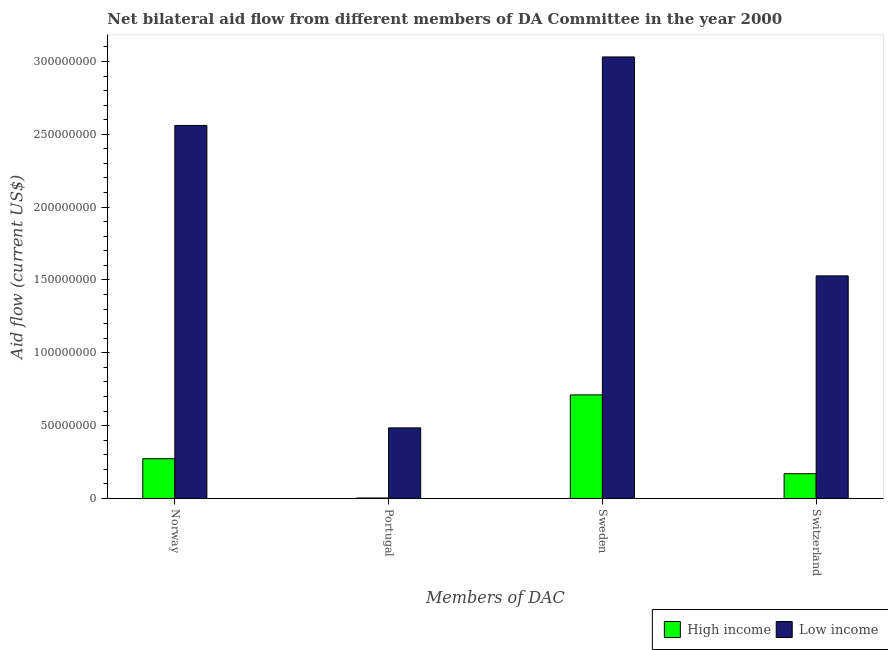How many different coloured bars are there?
Provide a succinct answer. 2. How many bars are there on the 4th tick from the left?
Make the answer very short. 2. How many bars are there on the 1st tick from the right?
Your answer should be very brief. 2. What is the amount of aid given by switzerland in High income?
Make the answer very short. 1.70e+07. Across all countries, what is the maximum amount of aid given by norway?
Offer a very short reply. 2.56e+08. Across all countries, what is the minimum amount of aid given by sweden?
Your answer should be compact. 7.11e+07. In which country was the amount of aid given by sweden maximum?
Your answer should be compact. Low income. What is the total amount of aid given by portugal in the graph?
Ensure brevity in your answer.  4.87e+07. What is the difference between the amount of aid given by norway in High income and that in Low income?
Offer a very short reply. -2.29e+08. What is the difference between the amount of aid given by norway in Low income and the amount of aid given by sweden in High income?
Your answer should be very brief. 1.85e+08. What is the average amount of aid given by sweden per country?
Provide a succinct answer. 1.87e+08. What is the difference between the amount of aid given by portugal and amount of aid given by switzerland in High income?
Ensure brevity in your answer.  -1.67e+07. In how many countries, is the amount of aid given by portugal greater than 70000000 US$?
Your answer should be very brief. 0. What is the ratio of the amount of aid given by norway in Low income to that in High income?
Make the answer very short. 9.39. Is the amount of aid given by norway in High income less than that in Low income?
Make the answer very short. Yes. What is the difference between the highest and the second highest amount of aid given by portugal?
Provide a succinct answer. 4.82e+07. What is the difference between the highest and the lowest amount of aid given by switzerland?
Your response must be concise. 1.36e+08. In how many countries, is the amount of aid given by sweden greater than the average amount of aid given by sweden taken over all countries?
Give a very brief answer. 1. What does the 1st bar from the left in Portugal represents?
Make the answer very short. High income. What does the 1st bar from the right in Switzerland represents?
Give a very brief answer. Low income. Is it the case that in every country, the sum of the amount of aid given by norway and amount of aid given by portugal is greater than the amount of aid given by sweden?
Your answer should be very brief. No. How many bars are there?
Give a very brief answer. 8. Are all the bars in the graph horizontal?
Offer a terse response. No. How many countries are there in the graph?
Offer a terse response. 2. Does the graph contain any zero values?
Ensure brevity in your answer.  No. Does the graph contain grids?
Make the answer very short. No. How many legend labels are there?
Make the answer very short. 2. What is the title of the graph?
Make the answer very short. Net bilateral aid flow from different members of DA Committee in the year 2000. What is the label or title of the X-axis?
Ensure brevity in your answer.  Members of DAC. What is the Aid flow (current US$) in High income in Norway?
Provide a short and direct response. 2.73e+07. What is the Aid flow (current US$) of Low income in Norway?
Give a very brief answer. 2.56e+08. What is the Aid flow (current US$) in Low income in Portugal?
Your response must be concise. 4.84e+07. What is the Aid flow (current US$) of High income in Sweden?
Keep it short and to the point. 7.11e+07. What is the Aid flow (current US$) in Low income in Sweden?
Ensure brevity in your answer.  3.03e+08. What is the Aid flow (current US$) of High income in Switzerland?
Ensure brevity in your answer.  1.70e+07. What is the Aid flow (current US$) in Low income in Switzerland?
Your answer should be very brief. 1.53e+08. Across all Members of DAC, what is the maximum Aid flow (current US$) in High income?
Offer a very short reply. 7.11e+07. Across all Members of DAC, what is the maximum Aid flow (current US$) in Low income?
Give a very brief answer. 3.03e+08. Across all Members of DAC, what is the minimum Aid flow (current US$) of High income?
Provide a succinct answer. 2.80e+05. Across all Members of DAC, what is the minimum Aid flow (current US$) of Low income?
Your answer should be compact. 4.84e+07. What is the total Aid flow (current US$) of High income in the graph?
Offer a very short reply. 1.16e+08. What is the total Aid flow (current US$) in Low income in the graph?
Make the answer very short. 7.60e+08. What is the difference between the Aid flow (current US$) in High income in Norway and that in Portugal?
Offer a very short reply. 2.70e+07. What is the difference between the Aid flow (current US$) in Low income in Norway and that in Portugal?
Offer a terse response. 2.08e+08. What is the difference between the Aid flow (current US$) of High income in Norway and that in Sweden?
Your answer should be compact. -4.38e+07. What is the difference between the Aid flow (current US$) in Low income in Norway and that in Sweden?
Provide a succinct answer. -4.70e+07. What is the difference between the Aid flow (current US$) in High income in Norway and that in Switzerland?
Ensure brevity in your answer.  1.03e+07. What is the difference between the Aid flow (current US$) of Low income in Norway and that in Switzerland?
Ensure brevity in your answer.  1.03e+08. What is the difference between the Aid flow (current US$) of High income in Portugal and that in Sweden?
Give a very brief answer. -7.08e+07. What is the difference between the Aid flow (current US$) in Low income in Portugal and that in Sweden?
Give a very brief answer. -2.55e+08. What is the difference between the Aid flow (current US$) of High income in Portugal and that in Switzerland?
Your response must be concise. -1.67e+07. What is the difference between the Aid flow (current US$) of Low income in Portugal and that in Switzerland?
Keep it short and to the point. -1.04e+08. What is the difference between the Aid flow (current US$) in High income in Sweden and that in Switzerland?
Provide a succinct answer. 5.41e+07. What is the difference between the Aid flow (current US$) in Low income in Sweden and that in Switzerland?
Offer a terse response. 1.50e+08. What is the difference between the Aid flow (current US$) in High income in Norway and the Aid flow (current US$) in Low income in Portugal?
Your answer should be very brief. -2.12e+07. What is the difference between the Aid flow (current US$) of High income in Norway and the Aid flow (current US$) of Low income in Sweden?
Ensure brevity in your answer.  -2.76e+08. What is the difference between the Aid flow (current US$) in High income in Norway and the Aid flow (current US$) in Low income in Switzerland?
Your answer should be compact. -1.26e+08. What is the difference between the Aid flow (current US$) of High income in Portugal and the Aid flow (current US$) of Low income in Sweden?
Keep it short and to the point. -3.03e+08. What is the difference between the Aid flow (current US$) in High income in Portugal and the Aid flow (current US$) in Low income in Switzerland?
Make the answer very short. -1.52e+08. What is the difference between the Aid flow (current US$) of High income in Sweden and the Aid flow (current US$) of Low income in Switzerland?
Keep it short and to the point. -8.17e+07. What is the average Aid flow (current US$) in High income per Members of DAC?
Make the answer very short. 2.89e+07. What is the average Aid flow (current US$) of Low income per Members of DAC?
Make the answer very short. 1.90e+08. What is the difference between the Aid flow (current US$) of High income and Aid flow (current US$) of Low income in Norway?
Your response must be concise. -2.29e+08. What is the difference between the Aid flow (current US$) in High income and Aid flow (current US$) in Low income in Portugal?
Make the answer very short. -4.82e+07. What is the difference between the Aid flow (current US$) of High income and Aid flow (current US$) of Low income in Sweden?
Keep it short and to the point. -2.32e+08. What is the difference between the Aid flow (current US$) in High income and Aid flow (current US$) in Low income in Switzerland?
Ensure brevity in your answer.  -1.36e+08. What is the ratio of the Aid flow (current US$) in High income in Norway to that in Portugal?
Ensure brevity in your answer.  97.39. What is the ratio of the Aid flow (current US$) of Low income in Norway to that in Portugal?
Keep it short and to the point. 5.29. What is the ratio of the Aid flow (current US$) in High income in Norway to that in Sweden?
Your answer should be compact. 0.38. What is the ratio of the Aid flow (current US$) of Low income in Norway to that in Sweden?
Offer a very short reply. 0.84. What is the ratio of the Aid flow (current US$) of High income in Norway to that in Switzerland?
Make the answer very short. 1.61. What is the ratio of the Aid flow (current US$) in Low income in Norway to that in Switzerland?
Give a very brief answer. 1.68. What is the ratio of the Aid flow (current US$) in High income in Portugal to that in Sweden?
Ensure brevity in your answer.  0. What is the ratio of the Aid flow (current US$) in Low income in Portugal to that in Sweden?
Provide a succinct answer. 0.16. What is the ratio of the Aid flow (current US$) of High income in Portugal to that in Switzerland?
Your answer should be compact. 0.02. What is the ratio of the Aid flow (current US$) in Low income in Portugal to that in Switzerland?
Offer a very short reply. 0.32. What is the ratio of the Aid flow (current US$) of High income in Sweden to that in Switzerland?
Offer a terse response. 4.19. What is the ratio of the Aid flow (current US$) in Low income in Sweden to that in Switzerland?
Provide a short and direct response. 1.98. What is the difference between the highest and the second highest Aid flow (current US$) in High income?
Provide a short and direct response. 4.38e+07. What is the difference between the highest and the second highest Aid flow (current US$) in Low income?
Make the answer very short. 4.70e+07. What is the difference between the highest and the lowest Aid flow (current US$) in High income?
Give a very brief answer. 7.08e+07. What is the difference between the highest and the lowest Aid flow (current US$) in Low income?
Your answer should be compact. 2.55e+08. 